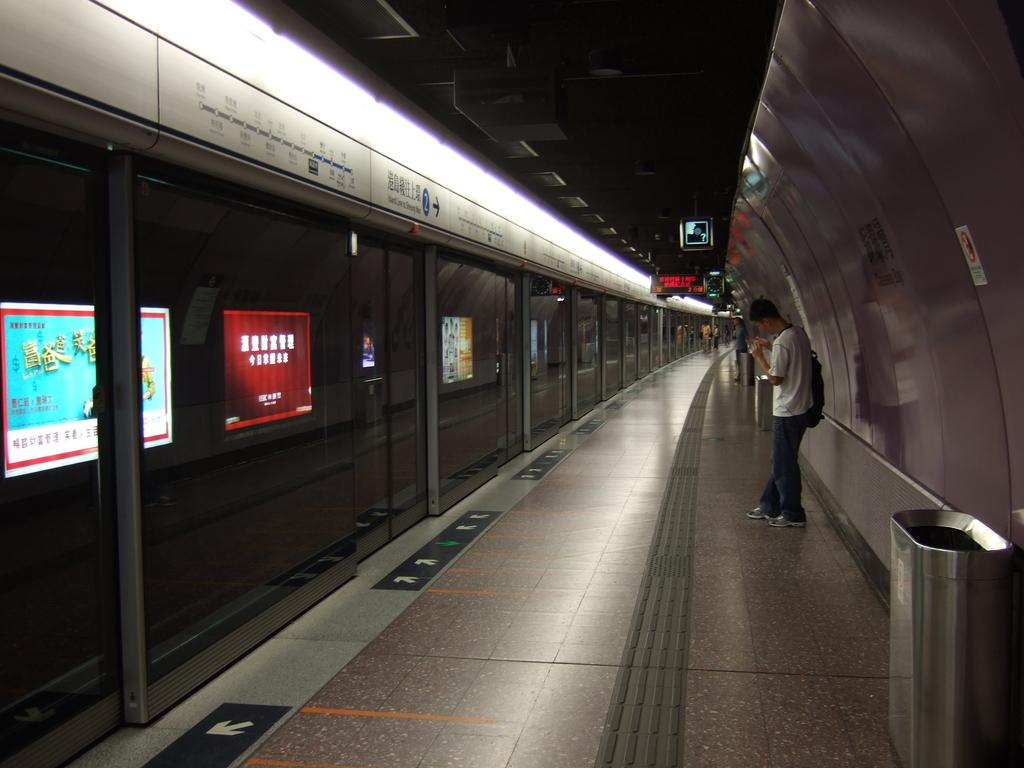What is the main structure in the image? There is a platform in the image. What can be seen on the platform? There is a display screen and advertisements in the image. Are there any people on the platform? Yes, there are persons on the platform. What else can be found on the platform? There are bins in the image. How many shelves are visible in the image? There are no shelves present in the image. Can you tell me how many times the persons on the platform sneeze in the image? There is no indication of anyone sneezing in the image. 